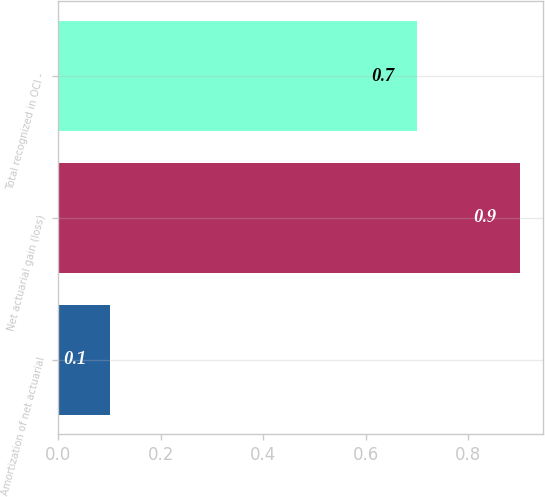Convert chart. <chart><loc_0><loc_0><loc_500><loc_500><bar_chart><fcel>Amortization of net actuarial<fcel>Net actuarial gain (loss)<fcel>Total recognized in OCI -<nl><fcel>0.1<fcel>0.9<fcel>0.7<nl></chart> 